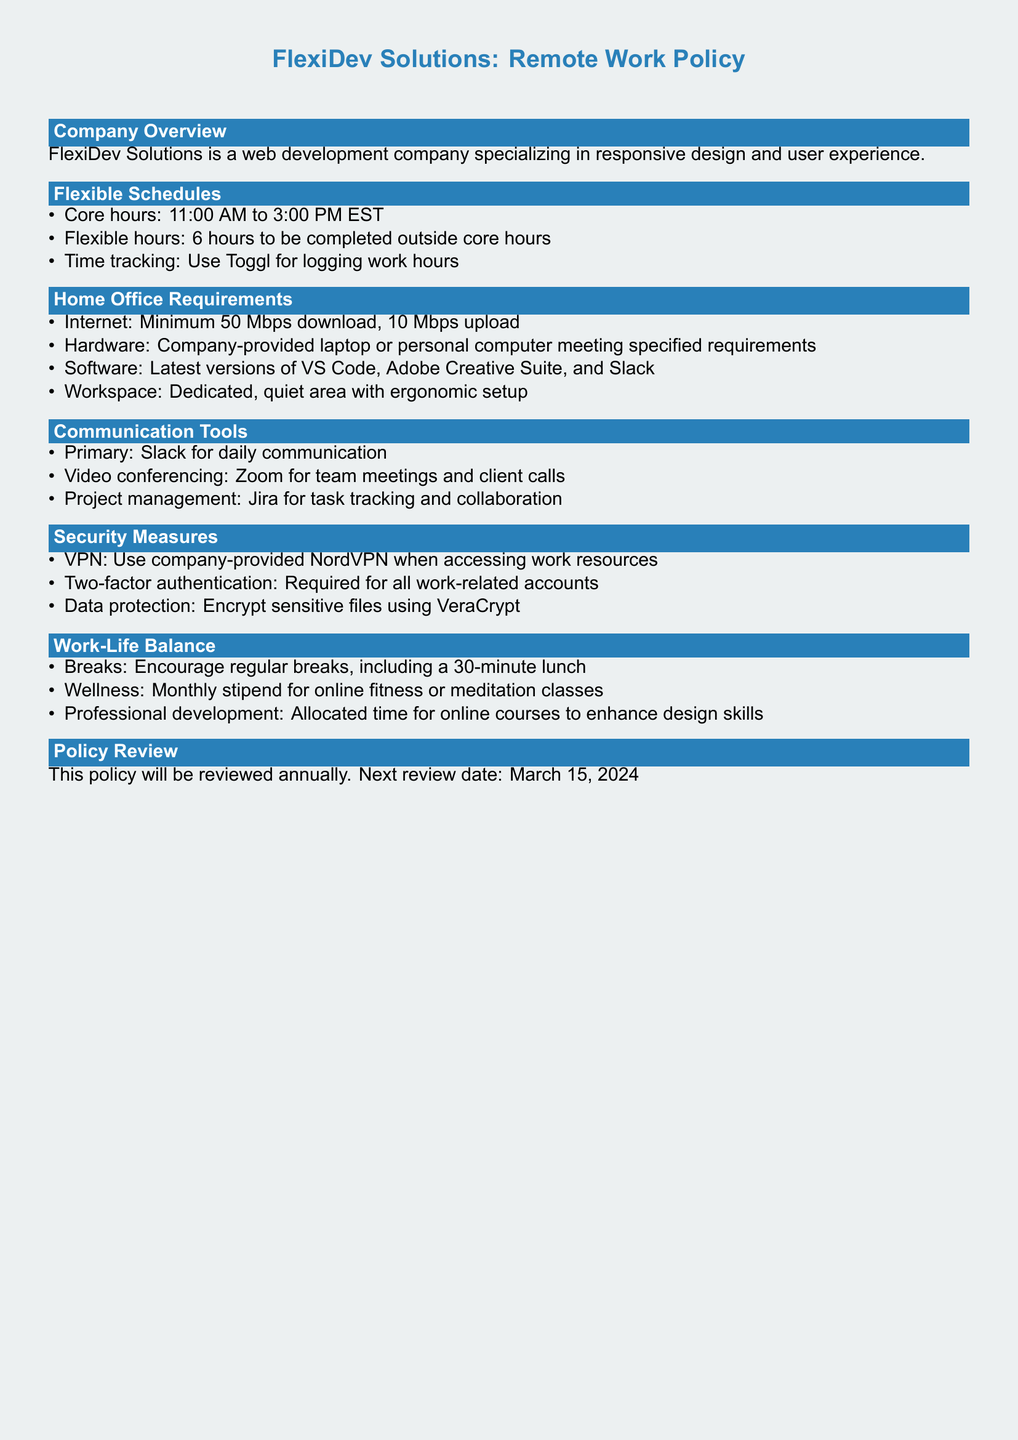What are the core hours for work? The core hours are specified in the Flexible Schedules section of the document.
Answer: 11:00 AM to 3:00 PM EST What is the minimum internet speed required? This requirement is listed under the Home Office Requirements section.
Answer: Minimum 50 Mbps download, 10 Mbps upload Which software must be installed? This information can be found in the Home Office Requirements section where software needs are outlined.
Answer: Latest versions of VS Code, Adobe Creative Suite, and Slack What is the monthly wellness stipend for? This detail is mentioned under the Work-Life Balance section of the document.
Answer: Online fitness or meditation classes When is the next policy review date? The next review date is noted in the Policy Review section of the document.
Answer: March 15, 2024 What tool is used for project management? This information is included in the Communication Tools section of the document.
Answer: Jira How many hours are flexible to be completed outside core hours? This detail is identified in the Flexible Schedules section where work hours are described.
Answer: 6 hours What is required for accessing work resources? This requirement is explained in the Security Measures section of the document.
Answer: Use company-provided NordVPN 